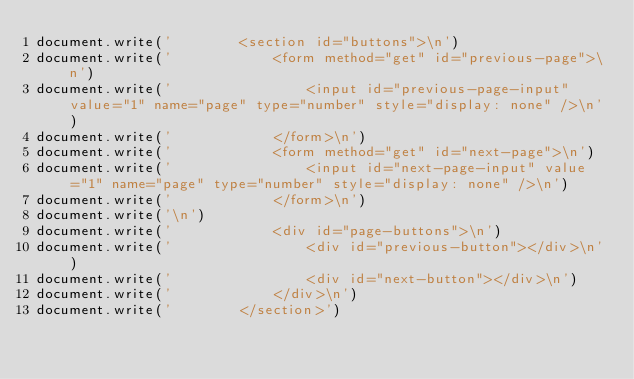Convert code to text. <code><loc_0><loc_0><loc_500><loc_500><_JavaScript_>document.write('		<section id="buttons">\n')
document.write('			<form method="get" id="previous-page">\n')
document.write('				<input id="previous-page-input" value="1" name="page" type="number" style="display: none" />\n')
document.write('			</form>\n')
document.write('			<form method="get" id="next-page">\n')
document.write('				<input id="next-page-input" value="1" name="page" type="number" style="display: none" />\n')
document.write('			</form>\n')
document.write('\n')
document.write('			<div id="page-buttons">\n')
document.write('				<div id="previous-button"></div>\n')
document.write('				<div id="next-button"></div>\n')
document.write('			</div>\n')
document.write('		</section>')
</code> 